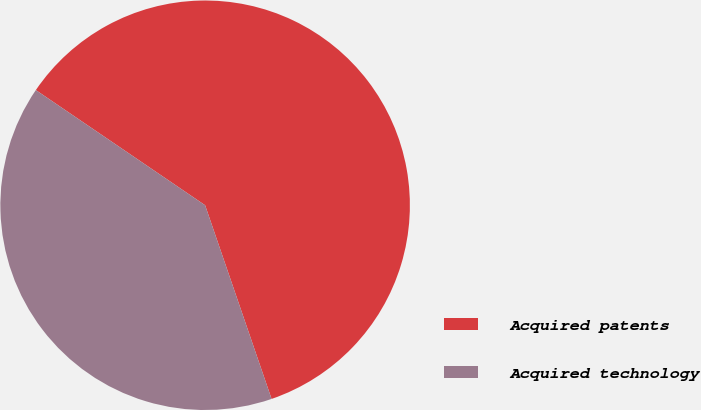Convert chart. <chart><loc_0><loc_0><loc_500><loc_500><pie_chart><fcel>Acquired patents<fcel>Acquired technology<nl><fcel>60.23%<fcel>39.77%<nl></chart> 